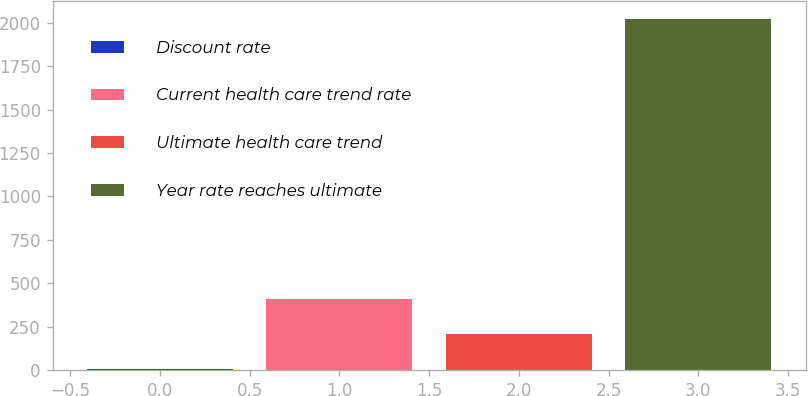Convert chart. <chart><loc_0><loc_0><loc_500><loc_500><bar_chart><fcel>Discount rate<fcel>Current health care trend rate<fcel>Ultimate health care trend<fcel>Year rate reaches ultimate<nl><fcel>4.6<fcel>408.28<fcel>206.44<fcel>2023<nl></chart> 